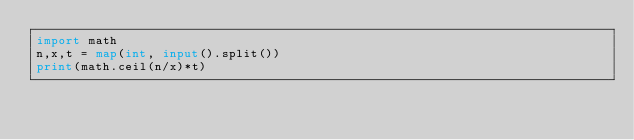Convert code to text. <code><loc_0><loc_0><loc_500><loc_500><_Python_>import math
n,x,t = map(int, input().split())
print(math.ceil(n/x)*t)
</code> 